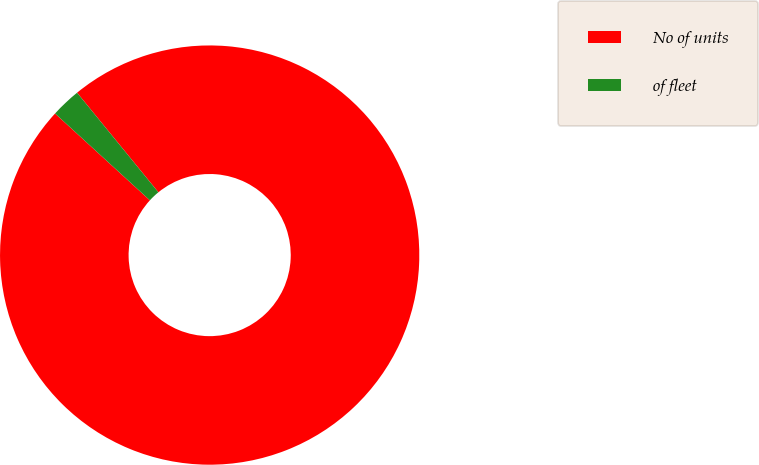Convert chart. <chart><loc_0><loc_0><loc_500><loc_500><pie_chart><fcel>No of units<fcel>of fleet<nl><fcel>97.7%<fcel>2.3%<nl></chart> 